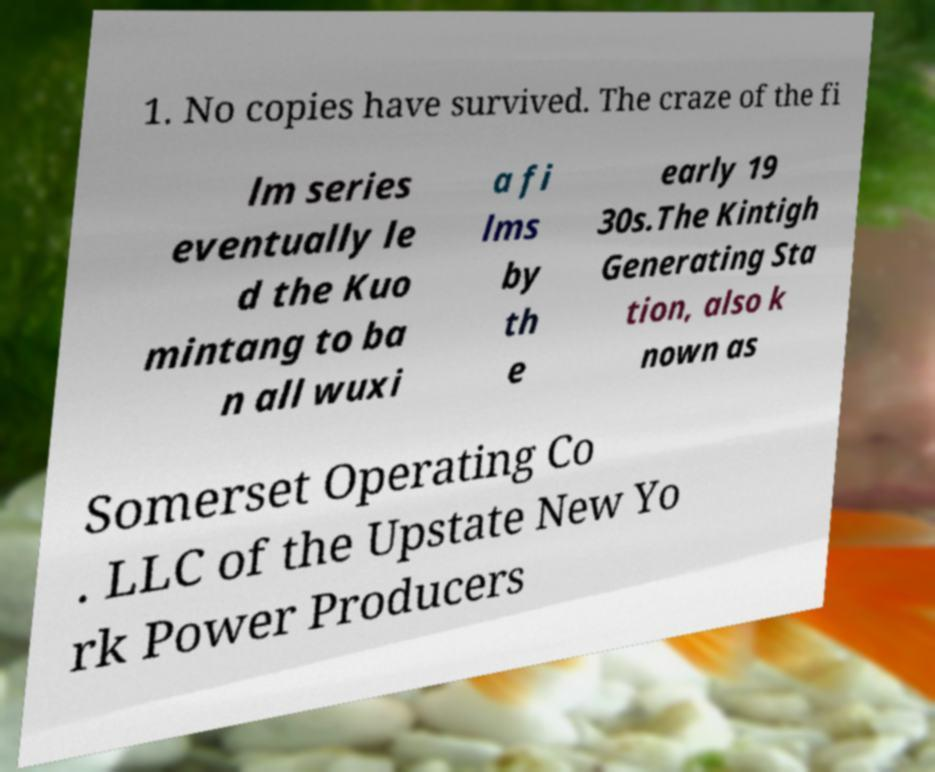Please read and relay the text visible in this image. What does it say? 1. No copies have survived. The craze of the fi lm series eventually le d the Kuo mintang to ba n all wuxi a fi lms by th e early 19 30s.The Kintigh Generating Sta tion, also k nown as Somerset Operating Co . LLC of the Upstate New Yo rk Power Producers 